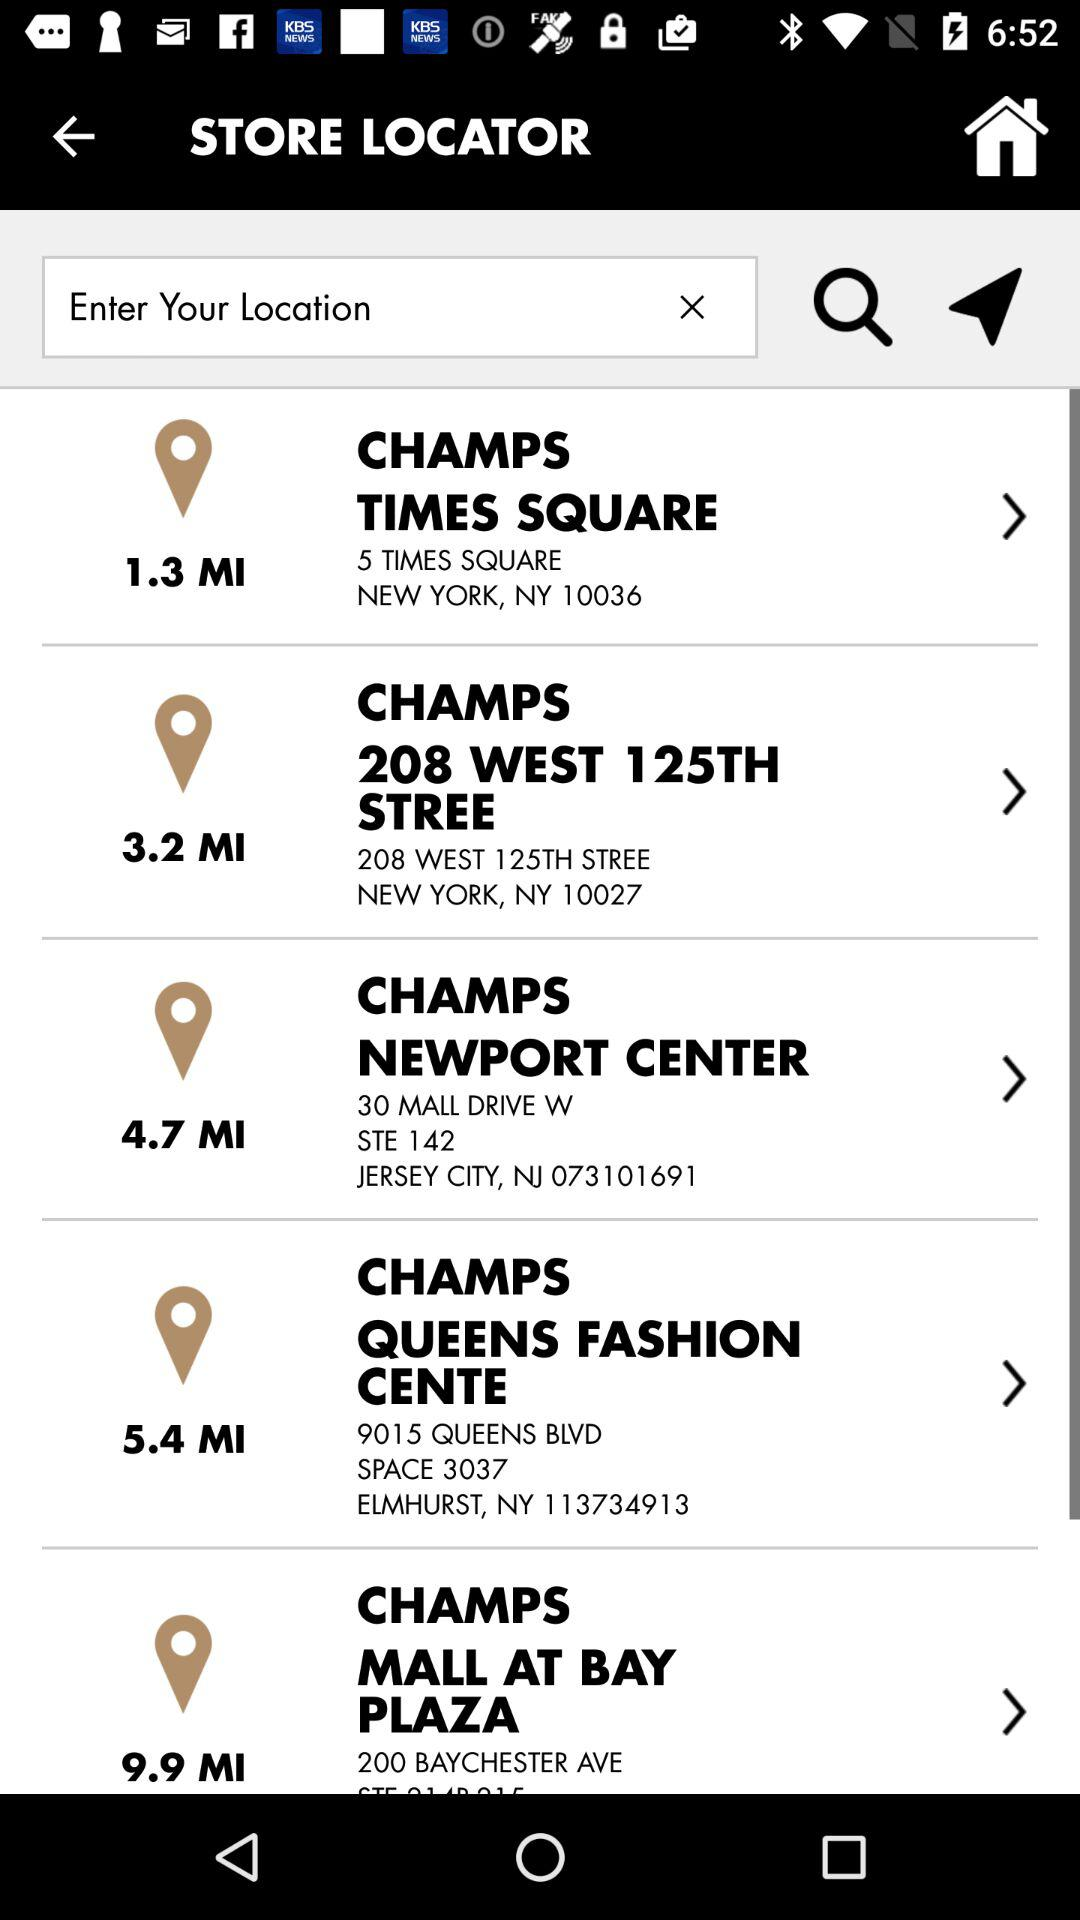How far is the "CHAMPS NEWPORT CENTER"? The "CHAMPS NEWPORT CENTER" is 4.7 miles away. 